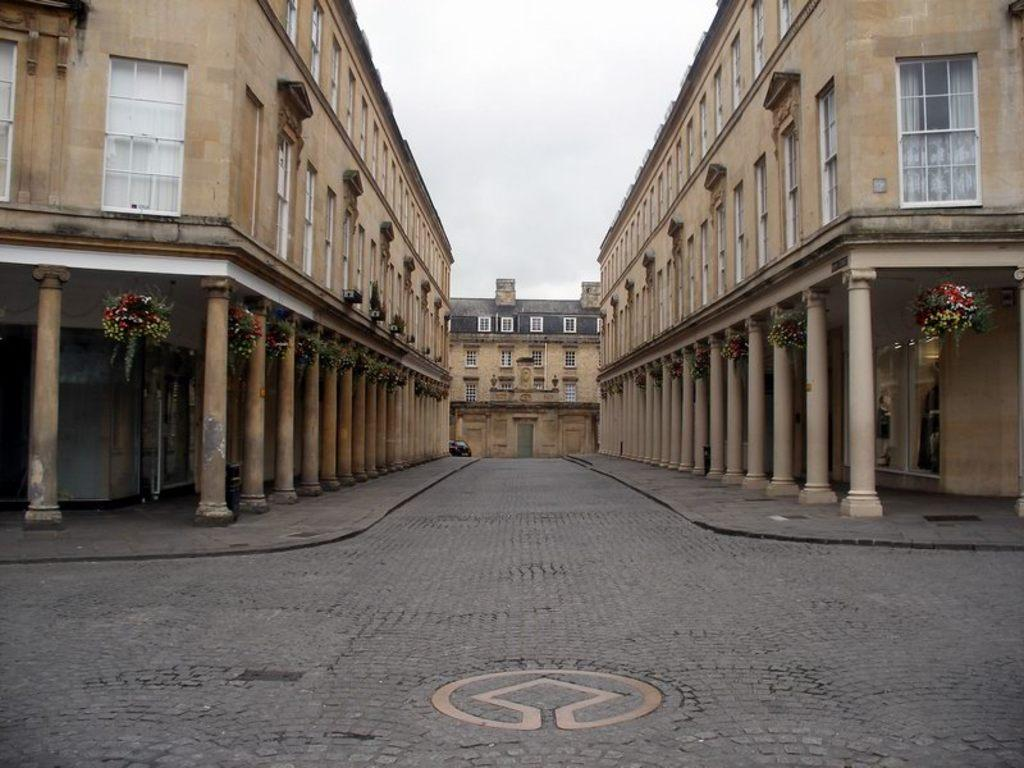What type of surface is visible in the image? There is a pavement in the image. What structures are located near the pavement? There are buildings around the pavement. What type of toys can be seen on the pavement in the image? There are no toys present on the pavement in the image. How many tomatoes are growing on the buildings in the image? There are no tomatoes visible on the buildings in the image. 